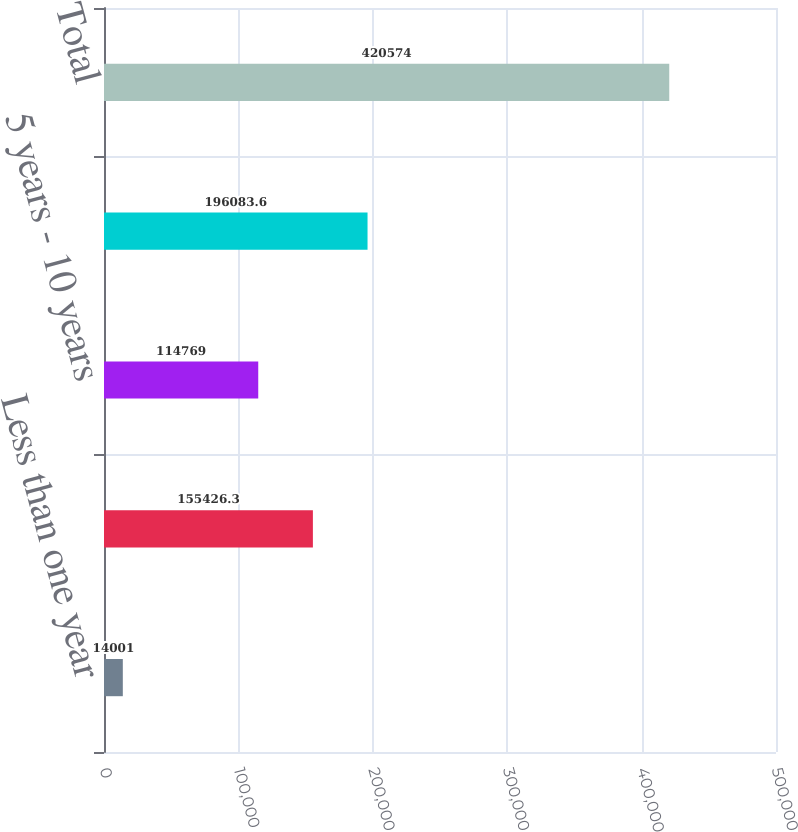Convert chart. <chart><loc_0><loc_0><loc_500><loc_500><bar_chart><fcel>Less than one year<fcel>1 year - 5 years<fcel>5 years - 10 years<fcel>Greater than 10 years<fcel>Total<nl><fcel>14001<fcel>155426<fcel>114769<fcel>196084<fcel>420574<nl></chart> 